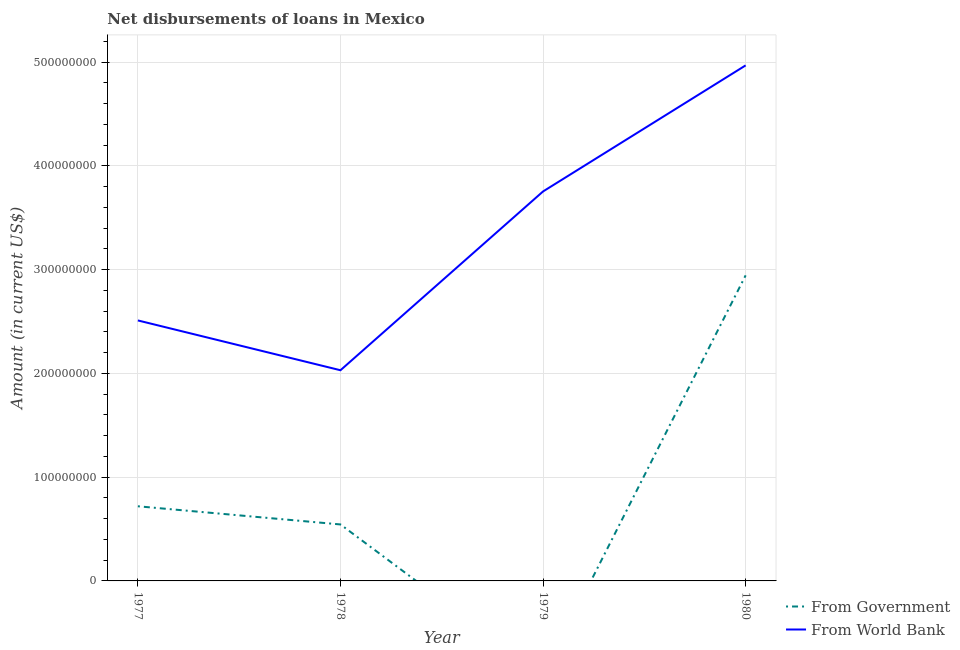Does the line corresponding to net disbursements of loan from government intersect with the line corresponding to net disbursements of loan from world bank?
Your answer should be compact. No. Is the number of lines equal to the number of legend labels?
Offer a very short reply. No. What is the net disbursements of loan from world bank in 1977?
Your answer should be very brief. 2.51e+08. Across all years, what is the maximum net disbursements of loan from world bank?
Offer a very short reply. 4.97e+08. In which year was the net disbursements of loan from world bank maximum?
Your response must be concise. 1980. What is the total net disbursements of loan from government in the graph?
Your answer should be compact. 4.21e+08. What is the difference between the net disbursements of loan from government in 1977 and that in 1980?
Offer a very short reply. -2.23e+08. What is the difference between the net disbursements of loan from world bank in 1980 and the net disbursements of loan from government in 1977?
Your response must be concise. 4.25e+08. What is the average net disbursements of loan from world bank per year?
Your answer should be compact. 3.32e+08. In the year 1980, what is the difference between the net disbursements of loan from government and net disbursements of loan from world bank?
Ensure brevity in your answer.  -2.02e+08. In how many years, is the net disbursements of loan from world bank greater than 220000000 US$?
Your answer should be compact. 3. What is the ratio of the net disbursements of loan from world bank in 1977 to that in 1978?
Offer a terse response. 1.24. What is the difference between the highest and the second highest net disbursements of loan from world bank?
Keep it short and to the point. 1.21e+08. What is the difference between the highest and the lowest net disbursements of loan from world bank?
Offer a very short reply. 2.94e+08. In how many years, is the net disbursements of loan from world bank greater than the average net disbursements of loan from world bank taken over all years?
Offer a terse response. 2. Does the net disbursements of loan from world bank monotonically increase over the years?
Offer a very short reply. No. Are the values on the major ticks of Y-axis written in scientific E-notation?
Your answer should be compact. No. Does the graph contain grids?
Offer a very short reply. Yes. What is the title of the graph?
Give a very brief answer. Net disbursements of loans in Mexico. Does "International Tourists" appear as one of the legend labels in the graph?
Make the answer very short. No. What is the label or title of the X-axis?
Provide a short and direct response. Year. What is the Amount (in current US$) in From Government in 1977?
Give a very brief answer. 7.19e+07. What is the Amount (in current US$) of From World Bank in 1977?
Your answer should be very brief. 2.51e+08. What is the Amount (in current US$) of From Government in 1978?
Provide a short and direct response. 5.44e+07. What is the Amount (in current US$) in From World Bank in 1978?
Make the answer very short. 2.03e+08. What is the Amount (in current US$) in From Government in 1979?
Give a very brief answer. 0. What is the Amount (in current US$) in From World Bank in 1979?
Ensure brevity in your answer.  3.75e+08. What is the Amount (in current US$) in From Government in 1980?
Your answer should be compact. 2.94e+08. What is the Amount (in current US$) of From World Bank in 1980?
Provide a short and direct response. 4.97e+08. Across all years, what is the maximum Amount (in current US$) in From Government?
Make the answer very short. 2.94e+08. Across all years, what is the maximum Amount (in current US$) of From World Bank?
Provide a short and direct response. 4.97e+08. Across all years, what is the minimum Amount (in current US$) of From World Bank?
Provide a short and direct response. 2.03e+08. What is the total Amount (in current US$) of From Government in the graph?
Your response must be concise. 4.21e+08. What is the total Amount (in current US$) of From World Bank in the graph?
Make the answer very short. 1.33e+09. What is the difference between the Amount (in current US$) of From Government in 1977 and that in 1978?
Make the answer very short. 1.75e+07. What is the difference between the Amount (in current US$) of From World Bank in 1977 and that in 1978?
Make the answer very short. 4.80e+07. What is the difference between the Amount (in current US$) in From World Bank in 1977 and that in 1979?
Make the answer very short. -1.24e+08. What is the difference between the Amount (in current US$) of From Government in 1977 and that in 1980?
Give a very brief answer. -2.23e+08. What is the difference between the Amount (in current US$) in From World Bank in 1977 and that in 1980?
Offer a terse response. -2.46e+08. What is the difference between the Amount (in current US$) of From World Bank in 1978 and that in 1979?
Provide a short and direct response. -1.72e+08. What is the difference between the Amount (in current US$) in From Government in 1978 and that in 1980?
Your answer should be compact. -2.40e+08. What is the difference between the Amount (in current US$) of From World Bank in 1978 and that in 1980?
Keep it short and to the point. -2.94e+08. What is the difference between the Amount (in current US$) in From World Bank in 1979 and that in 1980?
Provide a succinct answer. -1.21e+08. What is the difference between the Amount (in current US$) of From Government in 1977 and the Amount (in current US$) of From World Bank in 1978?
Keep it short and to the point. -1.31e+08. What is the difference between the Amount (in current US$) of From Government in 1977 and the Amount (in current US$) of From World Bank in 1979?
Ensure brevity in your answer.  -3.03e+08. What is the difference between the Amount (in current US$) of From Government in 1977 and the Amount (in current US$) of From World Bank in 1980?
Provide a short and direct response. -4.25e+08. What is the difference between the Amount (in current US$) of From Government in 1978 and the Amount (in current US$) of From World Bank in 1979?
Offer a terse response. -3.21e+08. What is the difference between the Amount (in current US$) of From Government in 1978 and the Amount (in current US$) of From World Bank in 1980?
Your answer should be compact. -4.42e+08. What is the average Amount (in current US$) of From Government per year?
Provide a succinct answer. 1.05e+08. What is the average Amount (in current US$) of From World Bank per year?
Your answer should be very brief. 3.32e+08. In the year 1977, what is the difference between the Amount (in current US$) of From Government and Amount (in current US$) of From World Bank?
Your response must be concise. -1.79e+08. In the year 1978, what is the difference between the Amount (in current US$) in From Government and Amount (in current US$) in From World Bank?
Your response must be concise. -1.49e+08. In the year 1980, what is the difference between the Amount (in current US$) of From Government and Amount (in current US$) of From World Bank?
Make the answer very short. -2.02e+08. What is the ratio of the Amount (in current US$) of From Government in 1977 to that in 1978?
Provide a short and direct response. 1.32. What is the ratio of the Amount (in current US$) of From World Bank in 1977 to that in 1978?
Offer a very short reply. 1.24. What is the ratio of the Amount (in current US$) in From World Bank in 1977 to that in 1979?
Your answer should be compact. 0.67. What is the ratio of the Amount (in current US$) in From Government in 1977 to that in 1980?
Your response must be concise. 0.24. What is the ratio of the Amount (in current US$) of From World Bank in 1977 to that in 1980?
Provide a short and direct response. 0.51. What is the ratio of the Amount (in current US$) in From World Bank in 1978 to that in 1979?
Give a very brief answer. 0.54. What is the ratio of the Amount (in current US$) of From Government in 1978 to that in 1980?
Offer a very short reply. 0.18. What is the ratio of the Amount (in current US$) of From World Bank in 1978 to that in 1980?
Offer a terse response. 0.41. What is the ratio of the Amount (in current US$) in From World Bank in 1979 to that in 1980?
Offer a very short reply. 0.76. What is the difference between the highest and the second highest Amount (in current US$) in From Government?
Provide a short and direct response. 2.23e+08. What is the difference between the highest and the second highest Amount (in current US$) in From World Bank?
Provide a succinct answer. 1.21e+08. What is the difference between the highest and the lowest Amount (in current US$) of From Government?
Keep it short and to the point. 2.94e+08. What is the difference between the highest and the lowest Amount (in current US$) of From World Bank?
Your answer should be very brief. 2.94e+08. 